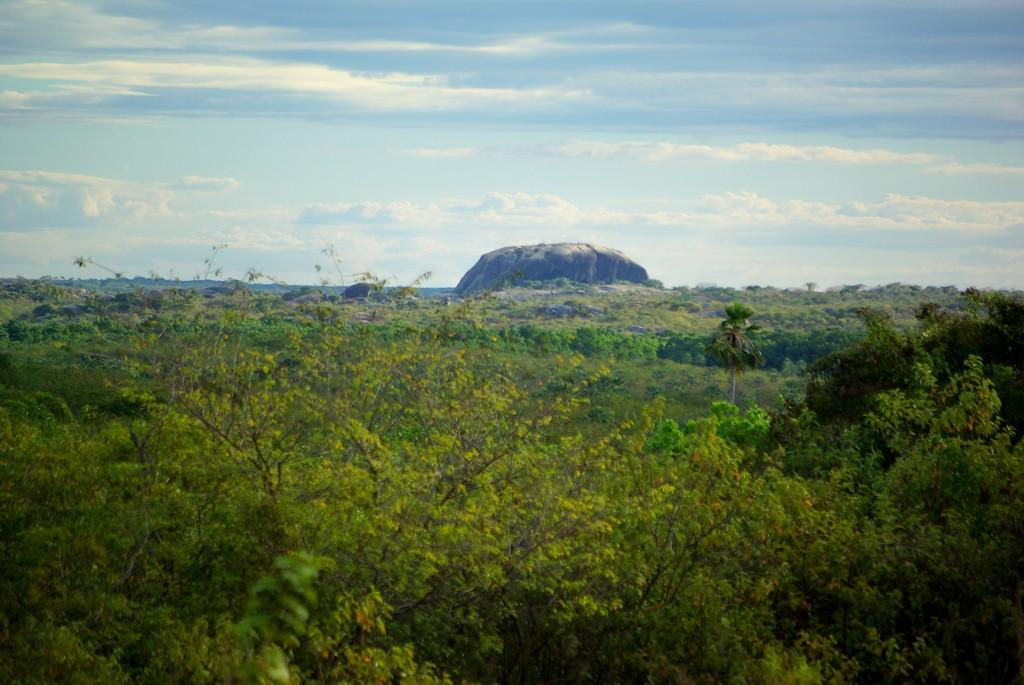What type of natural elements can be seen in the image? There are trees and rocks in the image. What is visible in the sky at the top of the image? There are clouds in the sky at the top of the image. What type of medical advice can be obtained from the doctor in the image? There is no doctor present in the image; it only features trees, rocks, and clouds. 